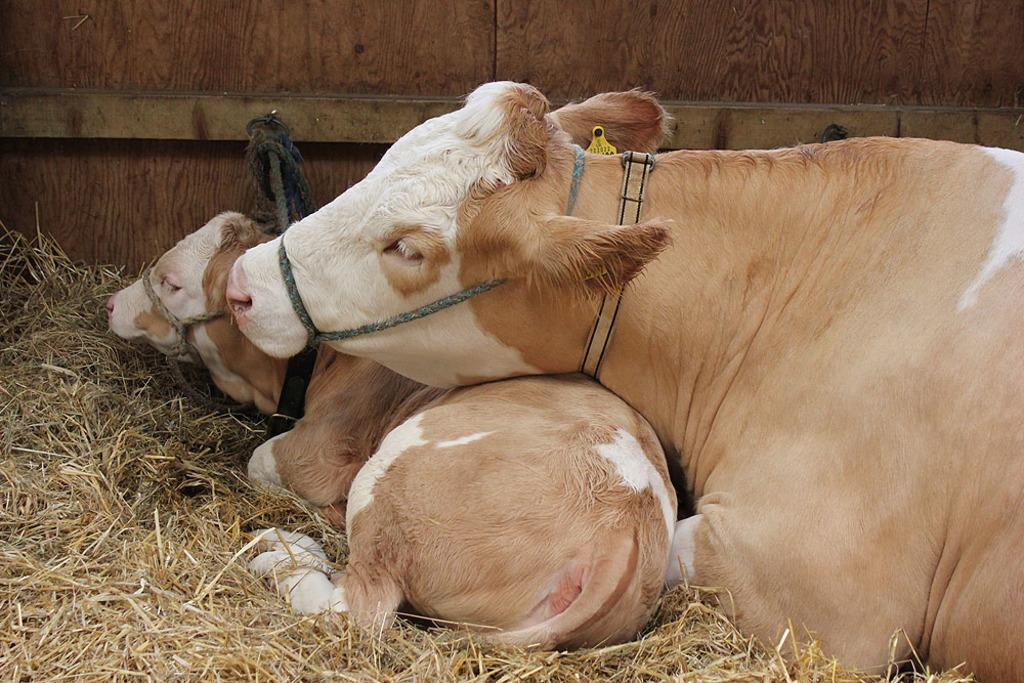What type of animals are in the image? There are cows in the image. What are the cows wearing in the image? The cows have belts on them. What type of vegetation is visible in the image? There is dried grass in the image. What other objects can be seen in the image? There are ropes in the image. What can be seen in the background of the image? There is a wooden wall in the background of the image. What idea does the cow have about the show in the image? There is no show or idea present in the image; it features cows with belts, dried grass, ropes, and a wooden wall in the background. 